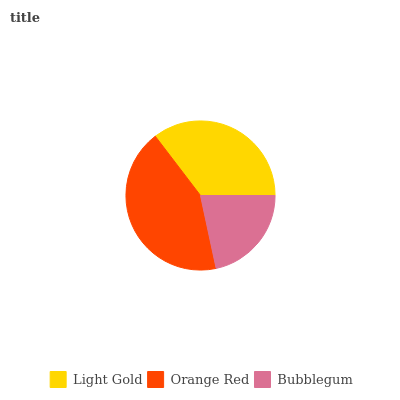Is Bubblegum the minimum?
Answer yes or no. Yes. Is Orange Red the maximum?
Answer yes or no. Yes. Is Orange Red the minimum?
Answer yes or no. No. Is Bubblegum the maximum?
Answer yes or no. No. Is Orange Red greater than Bubblegum?
Answer yes or no. Yes. Is Bubblegum less than Orange Red?
Answer yes or no. Yes. Is Bubblegum greater than Orange Red?
Answer yes or no. No. Is Orange Red less than Bubblegum?
Answer yes or no. No. Is Light Gold the high median?
Answer yes or no. Yes. Is Light Gold the low median?
Answer yes or no. Yes. Is Bubblegum the high median?
Answer yes or no. No. Is Bubblegum the low median?
Answer yes or no. No. 